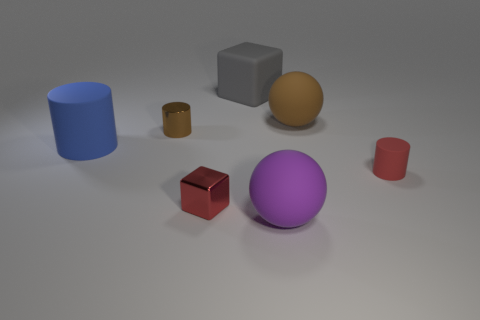Is the tiny matte cylinder the same color as the small metallic cube?
Ensure brevity in your answer.  Yes. How many things are either red things that are right of the gray object or large purple rubber spheres?
Provide a short and direct response. 2. Is there a red metal object that has the same size as the gray block?
Ensure brevity in your answer.  No. There is a tiny cylinder that is on the right side of the matte block; are there any large blue things right of it?
Ensure brevity in your answer.  No. What number of cylinders are either purple things or tiny red metal objects?
Your answer should be compact. 0. Are there any other large rubber objects of the same shape as the big brown rubber thing?
Your answer should be compact. Yes. What is the shape of the tiny brown shiny object?
Give a very brief answer. Cylinder. How many objects are either tiny rubber things or large things?
Your answer should be very brief. 5. Is the size of the ball that is right of the big purple ball the same as the rubber cylinder to the right of the purple rubber object?
Provide a short and direct response. No. What number of other objects are the same material as the tiny block?
Your answer should be very brief. 1. 